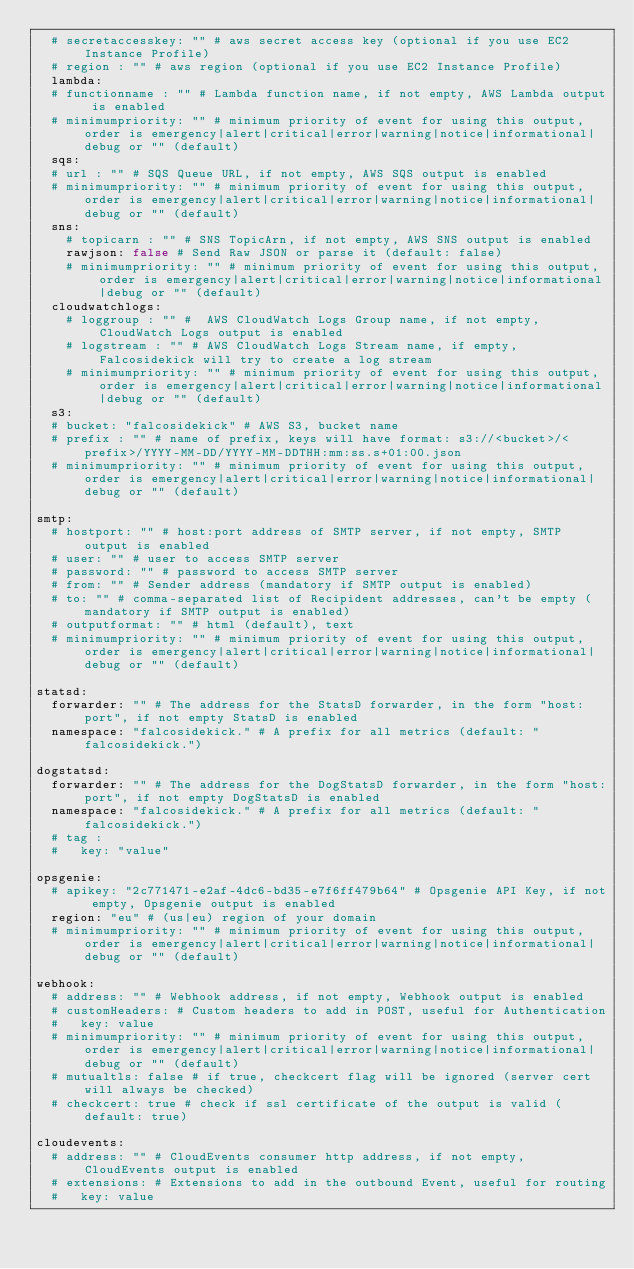Convert code to text. <code><loc_0><loc_0><loc_500><loc_500><_YAML_>  # secretaccesskey: "" # aws secret access key (optional if you use EC2 Instance Profile)
  # region : "" # aws region (optional if you use EC2 Instance Profile)
  lambda:
  # functionname : "" # Lambda function name, if not empty, AWS Lambda output is enabled
  # minimumpriority: "" # minimum priority of event for using this output, order is emergency|alert|critical|error|warning|notice|informational|debug or "" (default)
  sqs:
  # url : "" # SQS Queue URL, if not empty, AWS SQS output is enabled
  # minimumpriority: "" # minimum priority of event for using this output, order is emergency|alert|critical|error|warning|notice|informational|debug or "" (default)
  sns:
    # topicarn : "" # SNS TopicArn, if not empty, AWS SNS output is enabled
    rawjson: false # Send Raw JSON or parse it (default: false)
    # minimumpriority: "" # minimum priority of event for using this output, order is emergency|alert|critical|error|warning|notice|informational|debug or "" (default)
  cloudwatchlogs:
    # loggroup : "" #  AWS CloudWatch Logs Group name, if not empty, CloudWatch Logs output is enabled
    # logstream : "" # AWS CloudWatch Logs Stream name, if empty, Falcosidekick will try to create a log stream
    # minimumpriority: "" # minimum priority of event for using this output, order is emergency|alert|critical|error|warning|notice|informational|debug or "" (default)
  s3:
  # bucket: "falcosidekick" # AWS S3, bucket name
  # prefix : "" # name of prefix, keys will have format: s3://<bucket>/<prefix>/YYYY-MM-DD/YYYY-MM-DDTHH:mm:ss.s+01:00.json
  # minimumpriority: "" # minimum priority of event for using this output, order is emergency|alert|critical|error|warning|notice|informational|debug or "" (default)

smtp:
  # hostport: "" # host:port address of SMTP server, if not empty, SMTP output is enabled
  # user: "" # user to access SMTP server
  # password: "" # password to access SMTP server
  # from: "" # Sender address (mandatory if SMTP output is enabled)
  # to: "" # comma-separated list of Recipident addresses, can't be empty (mandatory if SMTP output is enabled)
  # outputformat: "" # html (default), text
  # minimumpriority: "" # minimum priority of event for using this output, order is emergency|alert|critical|error|warning|notice|informational|debug or "" (default)

statsd:
  forwarder: "" # The address for the StatsD forwarder, in the form "host:port", if not empty StatsD is enabled
  namespace: "falcosidekick." # A prefix for all metrics (default: "falcosidekick.")

dogstatsd:
  forwarder: "" # The address for the DogStatsD forwarder, in the form "host:port", if not empty DogStatsD is enabled
  namespace: "falcosidekick." # A prefix for all metrics (default: "falcosidekick.")
  # tag :
  #   key: "value"

opsgenie:
  # apikey: "2c771471-e2af-4dc6-bd35-e7f6ff479b64" # Opsgenie API Key, if not empty, Opsgenie output is enabled
  region: "eu" # (us|eu) region of your domain
  # minimumpriority: "" # minimum priority of event for using this output, order is emergency|alert|critical|error|warning|notice|informational|debug or "" (default)

webhook:
  # address: "" # Webhook address, if not empty, Webhook output is enabled
  # customHeaders: # Custom headers to add in POST, useful for Authentication
  #   key: value
  # minimumpriority: "" # minimum priority of event for using this output, order is emergency|alert|critical|error|warning|notice|informational|debug or "" (default)
  # mutualtls: false # if true, checkcert flag will be ignored (server cert will always be checked)
  # checkcert: true # check if ssl certificate of the output is valid (default: true)

cloudevents:
  # address: "" # CloudEvents consumer http address, if not empty, CloudEvents output is enabled
  # extensions: # Extensions to add in the outbound Event, useful for routing
  #   key: value</code> 